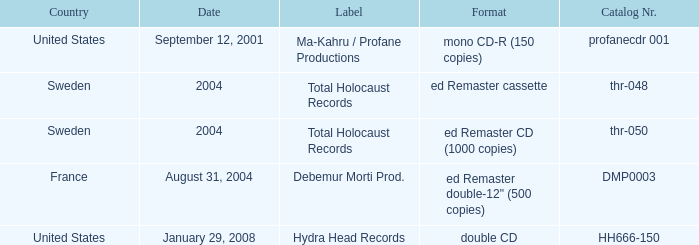Which country has the catalog nr of thr-048 in 2004? Sweden. 